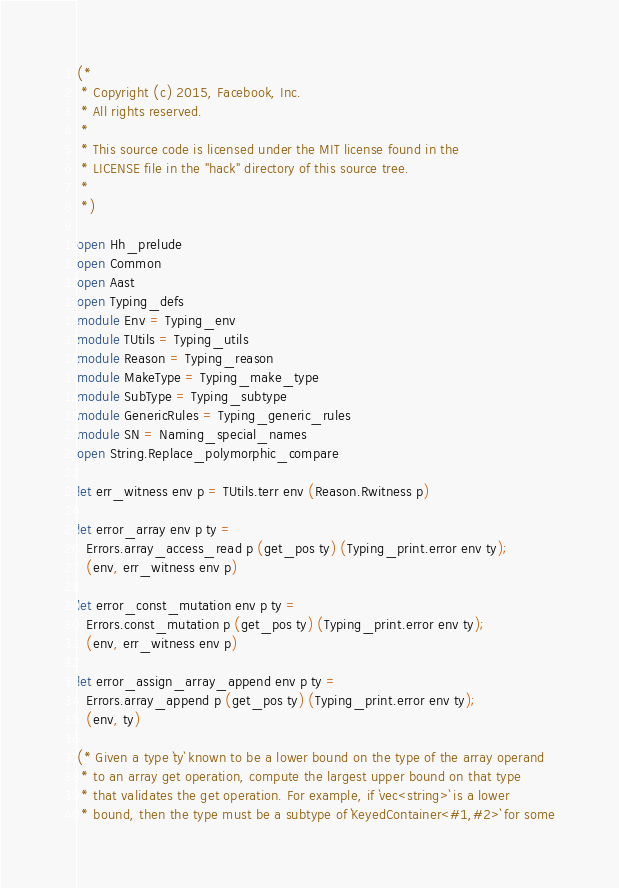<code> <loc_0><loc_0><loc_500><loc_500><_OCaml_>(*
 * Copyright (c) 2015, Facebook, Inc.
 * All rights reserved.
 *
 * This source code is licensed under the MIT license found in the
 * LICENSE file in the "hack" directory of this source tree.
 *
 *)

open Hh_prelude
open Common
open Aast
open Typing_defs
module Env = Typing_env
module TUtils = Typing_utils
module Reason = Typing_reason
module MakeType = Typing_make_type
module SubType = Typing_subtype
module GenericRules = Typing_generic_rules
module SN = Naming_special_names
open String.Replace_polymorphic_compare

let err_witness env p = TUtils.terr env (Reason.Rwitness p)

let error_array env p ty =
  Errors.array_access_read p (get_pos ty) (Typing_print.error env ty);
  (env, err_witness env p)

let error_const_mutation env p ty =
  Errors.const_mutation p (get_pos ty) (Typing_print.error env ty);
  (env, err_witness env p)

let error_assign_array_append env p ty =
  Errors.array_append p (get_pos ty) (Typing_print.error env ty);
  (env, ty)

(* Given a type `ty` known to be a lower bound on the type of the array operand
 * to an array get operation, compute the largest upper bound on that type
 * that validates the get operation. For example, if `vec<string>` is a lower
 * bound, then the type must be a subtype of `KeyedContainer<#1,#2>` for some</code> 